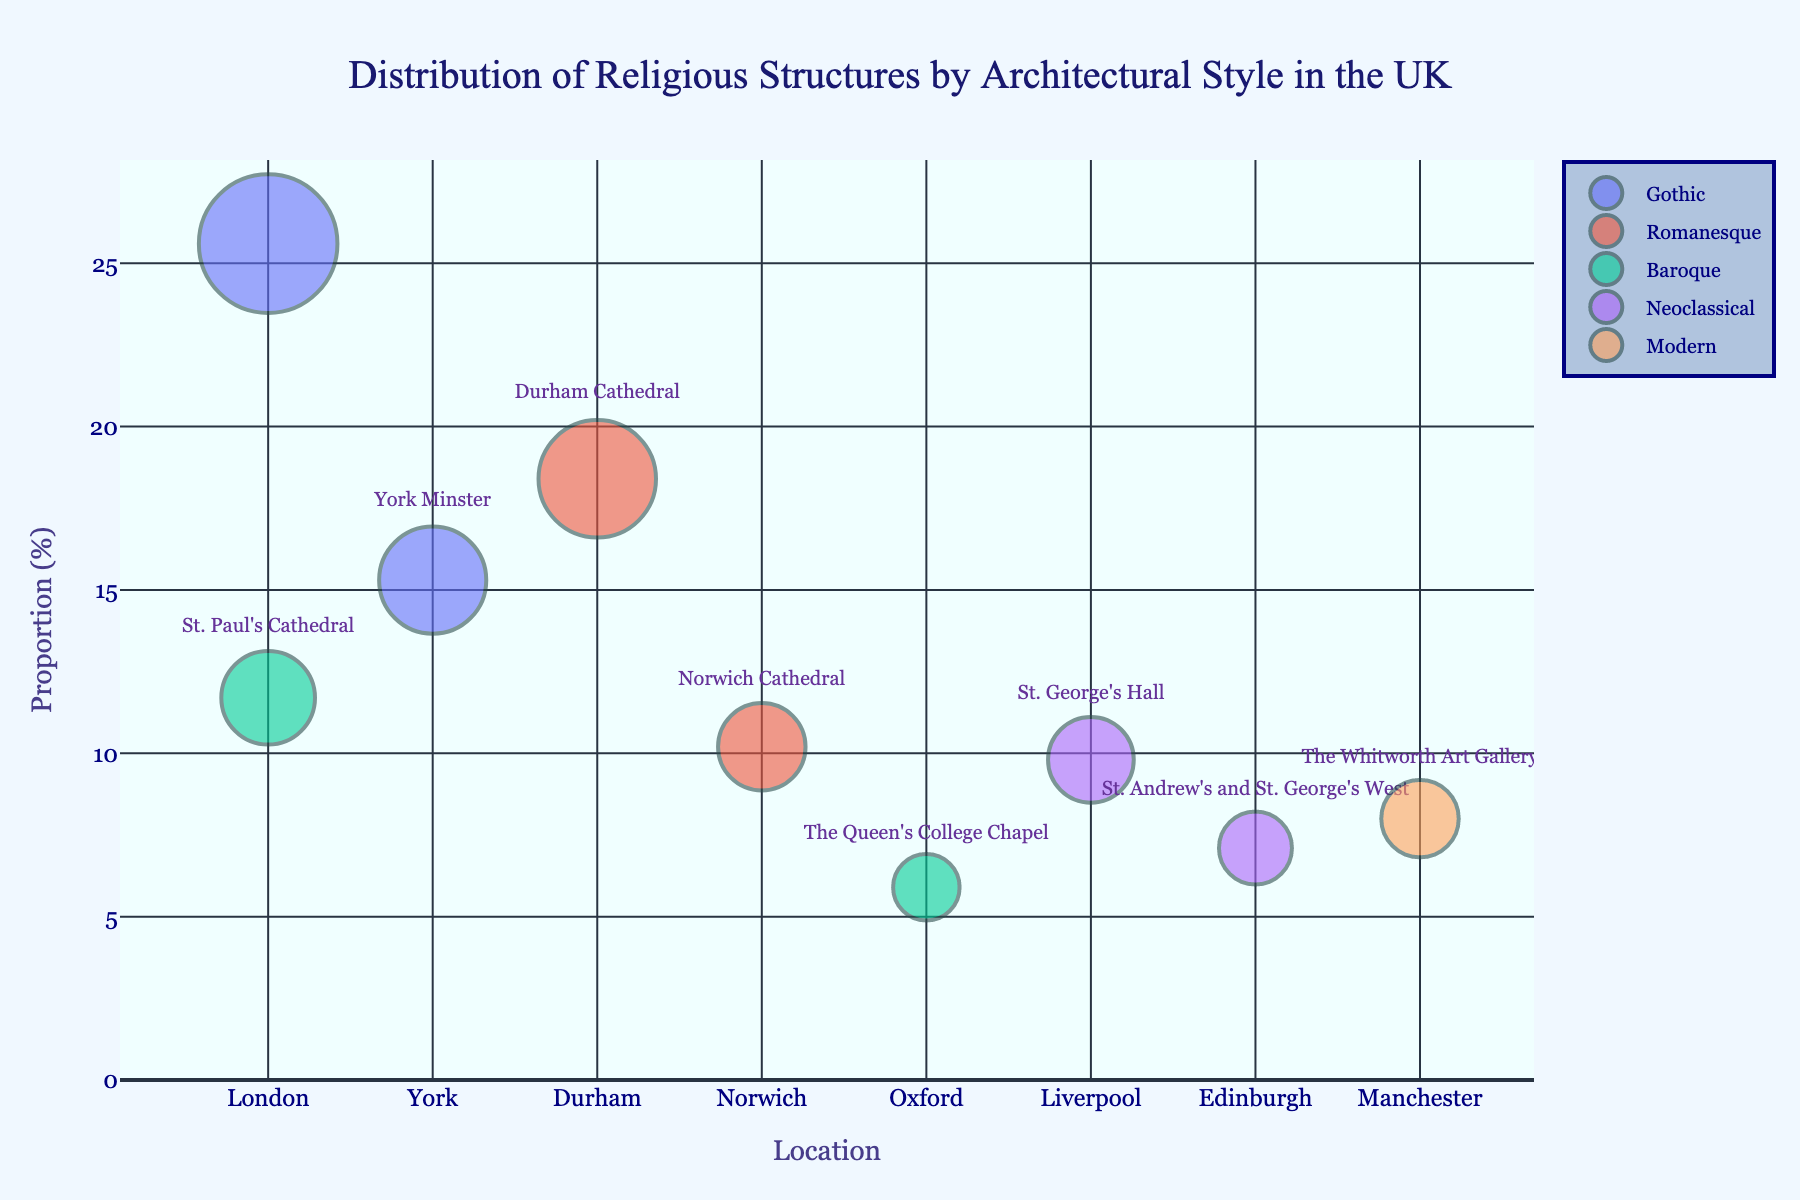What is the title of the figure? The title is clearly displayed at the top center of the chart. It reads: "Distribution of Religious Structures by Architectural Style in the UK".
Answer: Distribution of Religious Structures by Architectural Style in the UK What does the y-axis represent in this figure? The y-axis title indicates it represents the "Proportion (%)" of religious structures.
Answer: Proportion (%) Which architectural style has the largest proportion in London? By looking at the size of the bubbles, the largest bubble in London belongs to the Gothic style.
Answer: Gothic What are the prominent examples of Gothic architecture in London and York? The prominent examples are shown by the labels inside the bubbles. For London, it's Westminster Abbey, and for York, it's York Minster.
Answer: Westminster Abbey and York Minster How many architectural styles are represented in the figure? Each unique color represents a different architectural style, and counting them gives us the number of styles. There are five styles: Gothic, Romanesque, Baroque, Neoclassical, and Modern.
Answer: Five Which city has the highest proportion of Romanesque structures, and what is the value? Look at the Romanesque bubbles and compare their proportions. Durham has the highest at 18.4%.
Answer: Durham, 18.4% What is the combined proportion of Baroque structures in London and Oxford? Add the proportions for Baroque in London (11.7%) and Oxford (5.9%). The sum is 11.7% + 5.9% = 17.6%.
Answer: 17.6% Which architectural style has the smallest representation in the figure, and where is it located? By comparing the smallest bubble for each city, Neoclassical in Edinburgh has the smallest proportion (7.1%).
Answer: Neoclassical in Edinburgh How does the proportion of Gothic structures in York compare to those in London? Compare the proportions of Gothic structures: York has 15.3% and London has 25.6%. York's proportion is smaller.
Answer: Less Where can you find an example of Modern architecture in this figure? The bubble labeled as Modern is found in Manchester, identified by "The Whitworth Art Gallery".
Answer: Manchester 